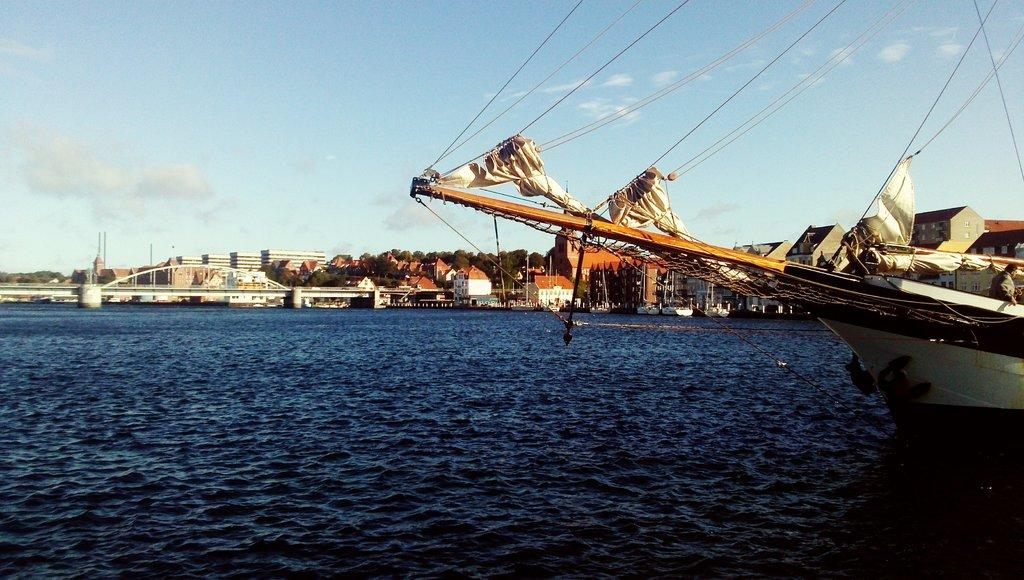What is the main feature of the image? There is water in the image. What is on the water? There are ships on the water. What can be seen in the background of the image? There is a bridge, buildings, and trees in the background of the image. What is visible at the top of the image? The sky is visible at the top of the image. Where is the bat located in the image? There is no bat present in the image. What is the purpose of the stop sign in the image? There is no stop sign present in the image. 